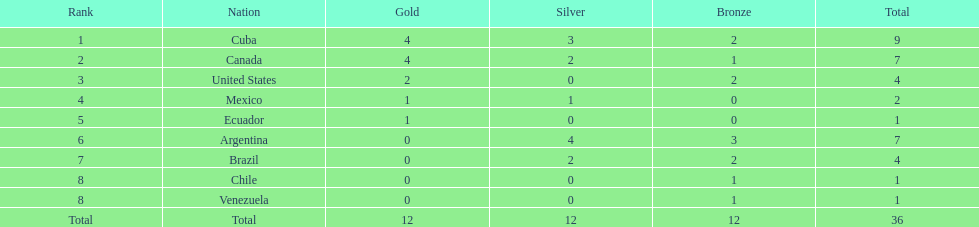Who is ranked #1? Cuba. 